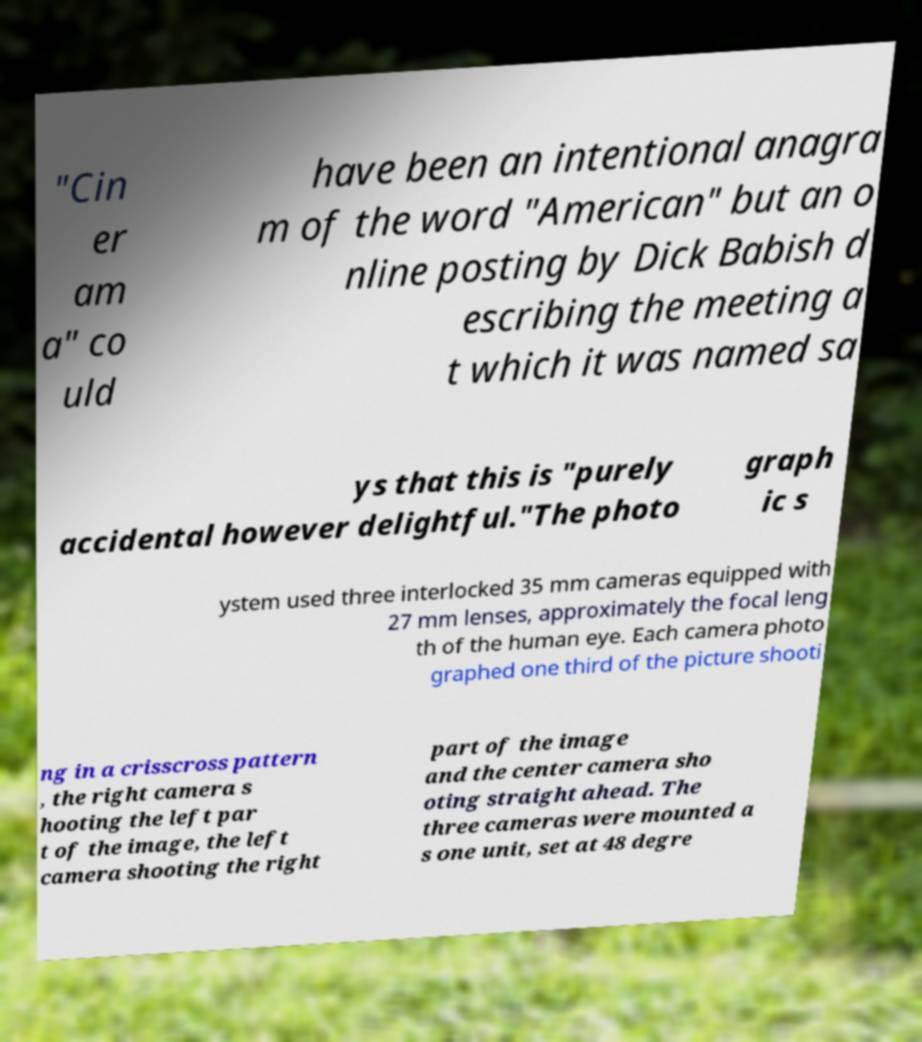Can you accurately transcribe the text from the provided image for me? "Cin er am a" co uld have been an intentional anagra m of the word "American" but an o nline posting by Dick Babish d escribing the meeting a t which it was named sa ys that this is "purely accidental however delightful."The photo graph ic s ystem used three interlocked 35 mm cameras equipped with 27 mm lenses, approximately the focal leng th of the human eye. Each camera photo graphed one third of the picture shooti ng in a crisscross pattern , the right camera s hooting the left par t of the image, the left camera shooting the right part of the image and the center camera sho oting straight ahead. The three cameras were mounted a s one unit, set at 48 degre 